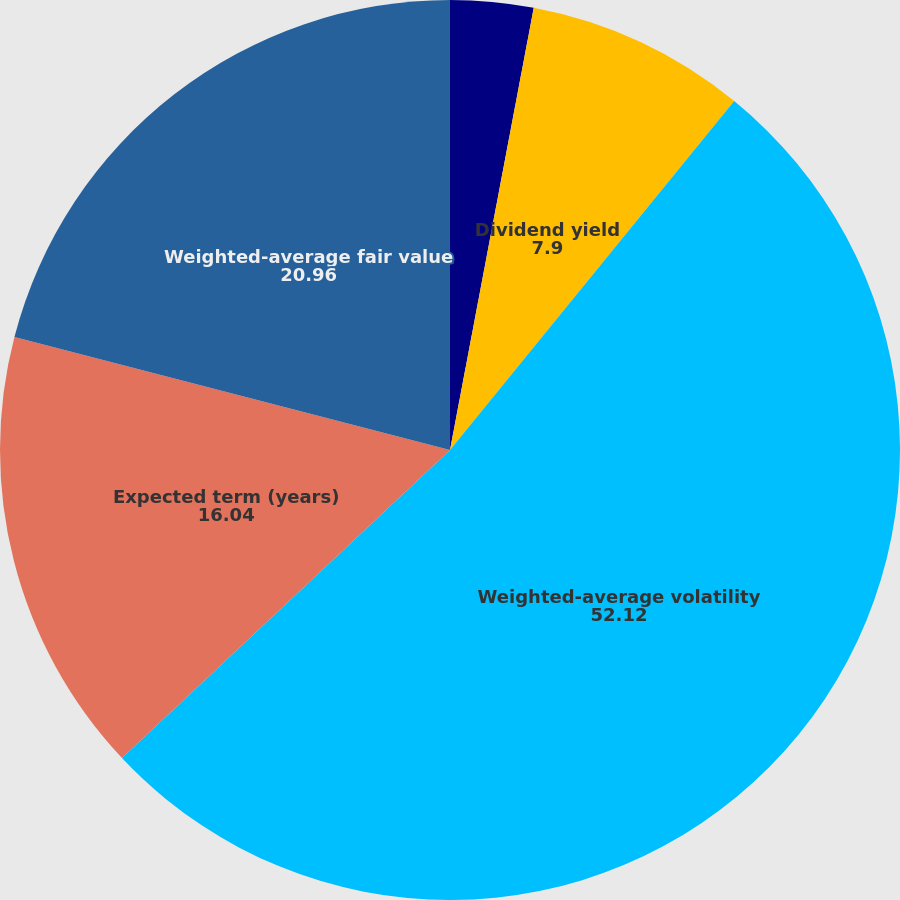Convert chart to OTSL. <chart><loc_0><loc_0><loc_500><loc_500><pie_chart><fcel>Risk-free interest rate<fcel>Dividend yield<fcel>Weighted-average volatility<fcel>Expected term (years)<fcel>Weighted-average fair value<nl><fcel>2.98%<fcel>7.9%<fcel>52.12%<fcel>16.04%<fcel>20.96%<nl></chart> 